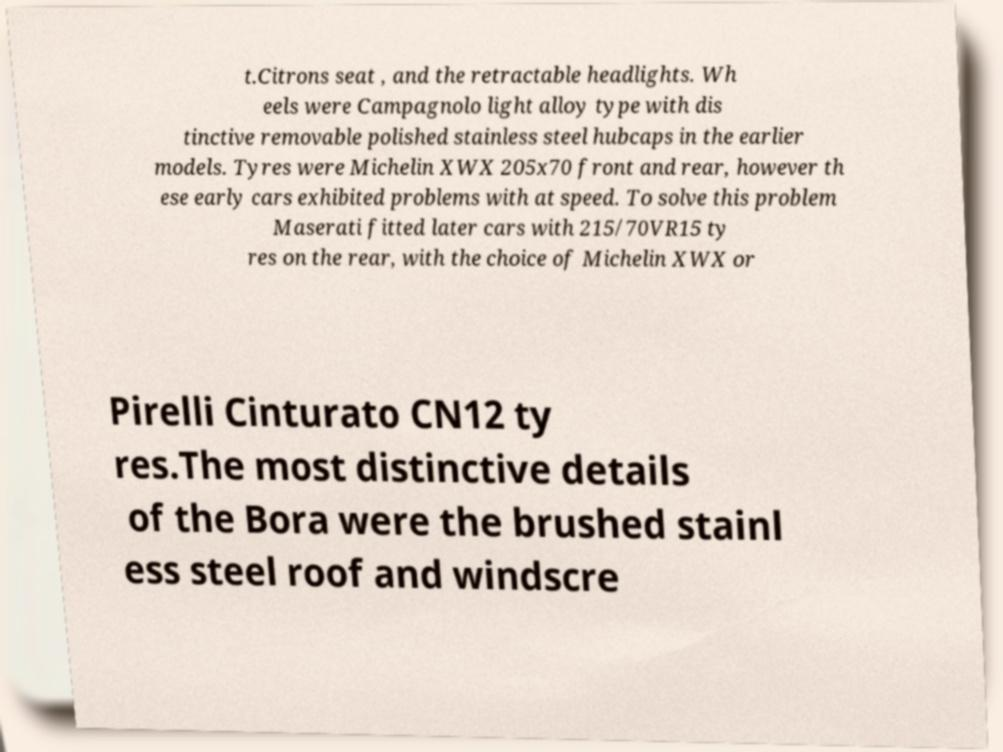There's text embedded in this image that I need extracted. Can you transcribe it verbatim? t.Citrons seat , and the retractable headlights. Wh eels were Campagnolo light alloy type with dis tinctive removable polished stainless steel hubcaps in the earlier models. Tyres were Michelin XWX 205x70 front and rear, however th ese early cars exhibited problems with at speed. To solve this problem Maserati fitted later cars with 215/70VR15 ty res on the rear, with the choice of Michelin XWX or Pirelli Cinturato CN12 ty res.The most distinctive details of the Bora were the brushed stainl ess steel roof and windscre 